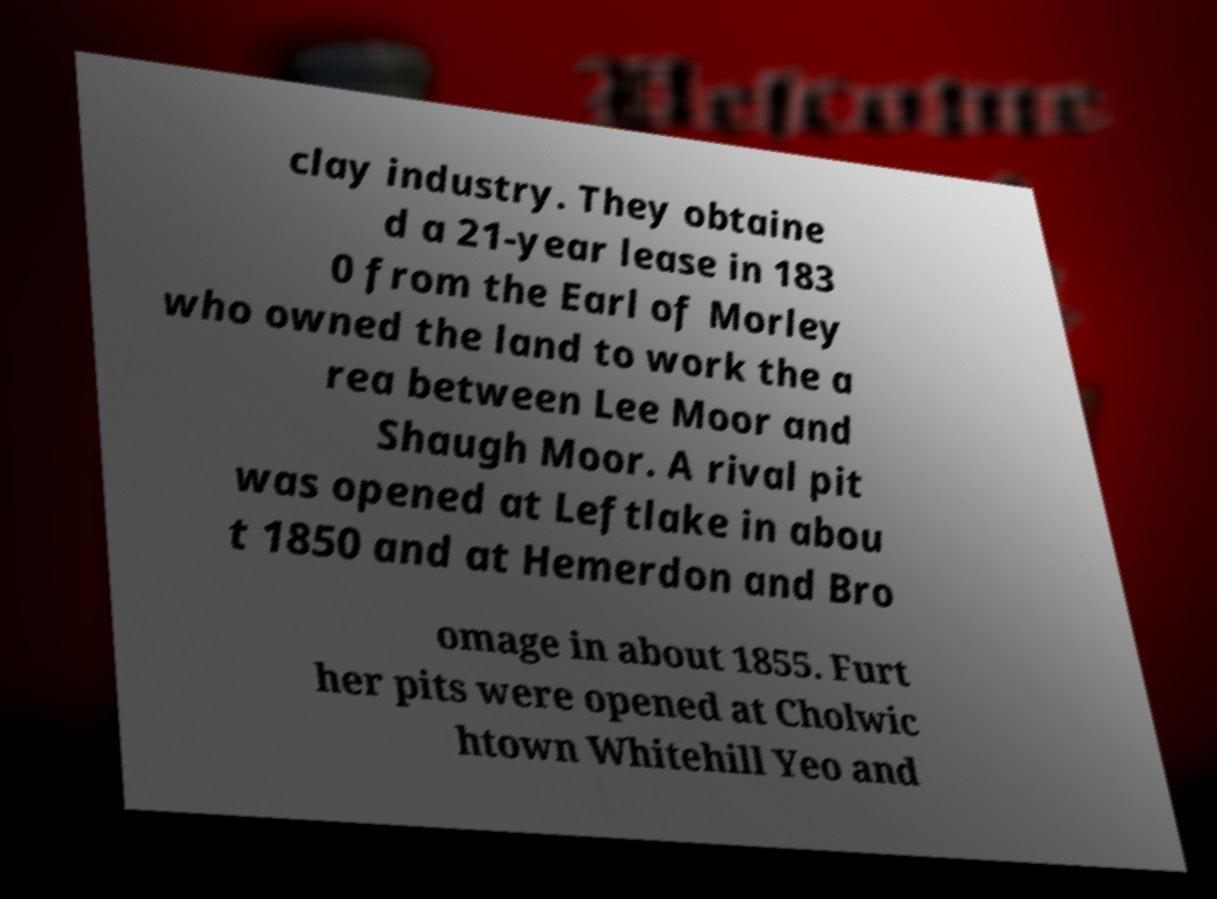There's text embedded in this image that I need extracted. Can you transcribe it verbatim? clay industry. They obtaine d a 21-year lease in 183 0 from the Earl of Morley who owned the land to work the a rea between Lee Moor and Shaugh Moor. A rival pit was opened at Leftlake in abou t 1850 and at Hemerdon and Bro omage in about 1855. Furt her pits were opened at Cholwic htown Whitehill Yeo and 